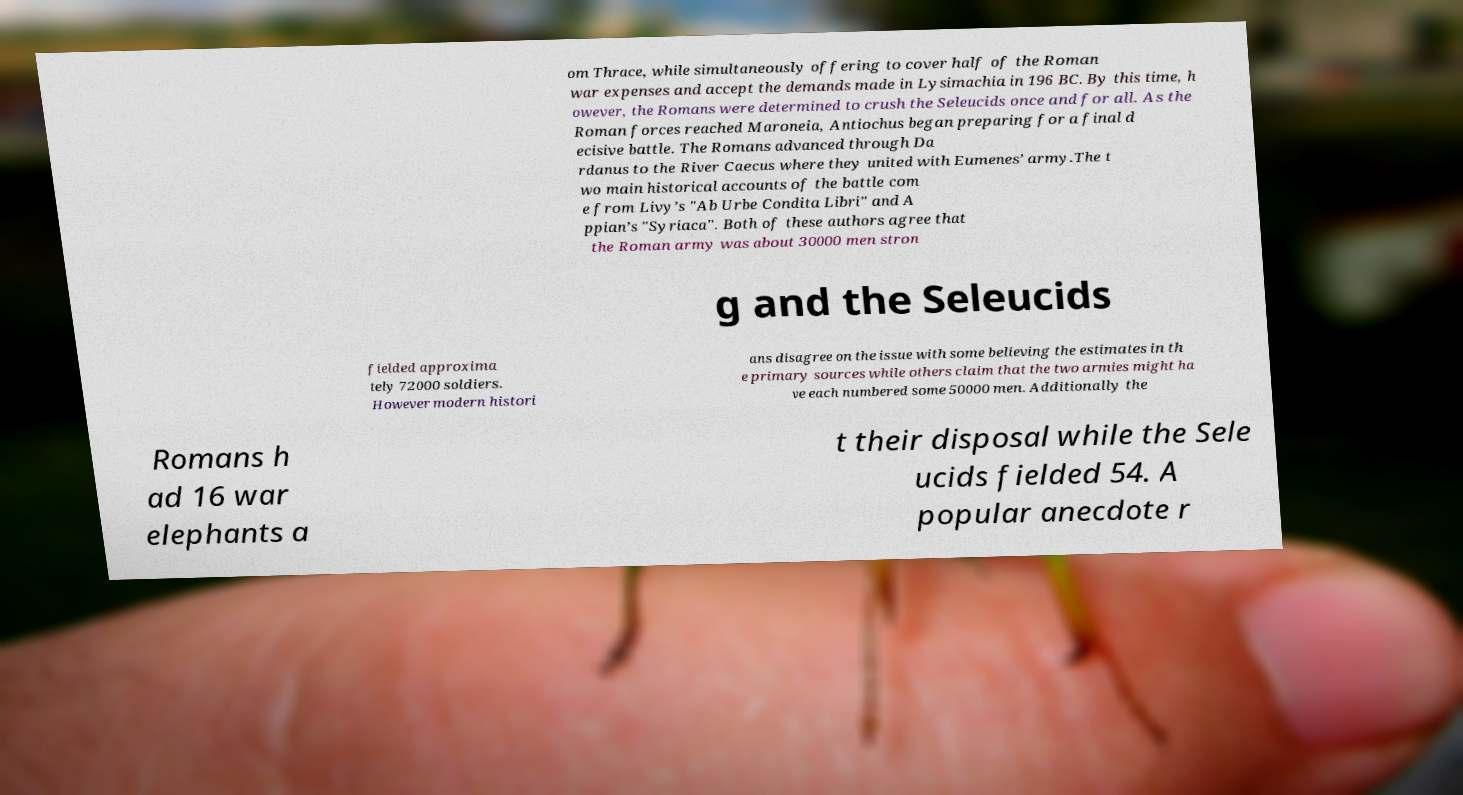What messages or text are displayed in this image? I need them in a readable, typed format. om Thrace, while simultaneously offering to cover half of the Roman war expenses and accept the demands made in Lysimachia in 196 BC. By this time, h owever, the Romans were determined to crush the Seleucids once and for all. As the Roman forces reached Maroneia, Antiochus began preparing for a final d ecisive battle. The Romans advanced through Da rdanus to the River Caecus where they united with Eumenes’ army.The t wo main historical accounts of the battle com e from Livy’s "Ab Urbe Condita Libri" and A ppian’s "Syriaca". Both of these authors agree that the Roman army was about 30000 men stron g and the Seleucids fielded approxima tely 72000 soldiers. However modern histori ans disagree on the issue with some believing the estimates in th e primary sources while others claim that the two armies might ha ve each numbered some 50000 men. Additionally the Romans h ad 16 war elephants a t their disposal while the Sele ucids fielded 54. A popular anecdote r 